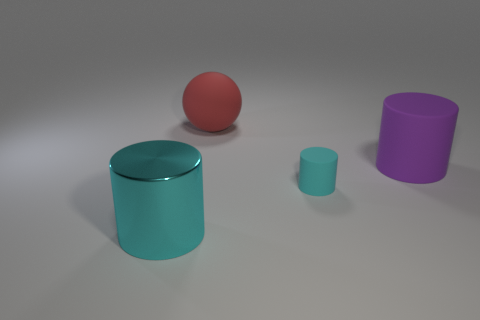Are there any other cylinders of the same color as the metallic cylinder?
Your answer should be compact. Yes. How many large objects are either brown rubber balls or rubber objects?
Give a very brief answer. 2. How many small yellow metal cylinders are there?
Provide a short and direct response. 0. What is the material of the large cylinder left of the tiny object?
Provide a succinct answer. Metal. Are there any matte cylinders behind the large purple matte thing?
Your response must be concise. No. Is the shiny cylinder the same size as the cyan matte object?
Offer a very short reply. No. How many purple cylinders have the same material as the large cyan cylinder?
Make the answer very short. 0. There is a cyan cylinder that is behind the cylinder that is on the left side of the large red thing; how big is it?
Ensure brevity in your answer.  Small. What color is the rubber thing that is behind the cyan matte cylinder and on the right side of the red ball?
Your answer should be compact. Purple. Do the tiny object and the large purple object have the same shape?
Make the answer very short. Yes. 